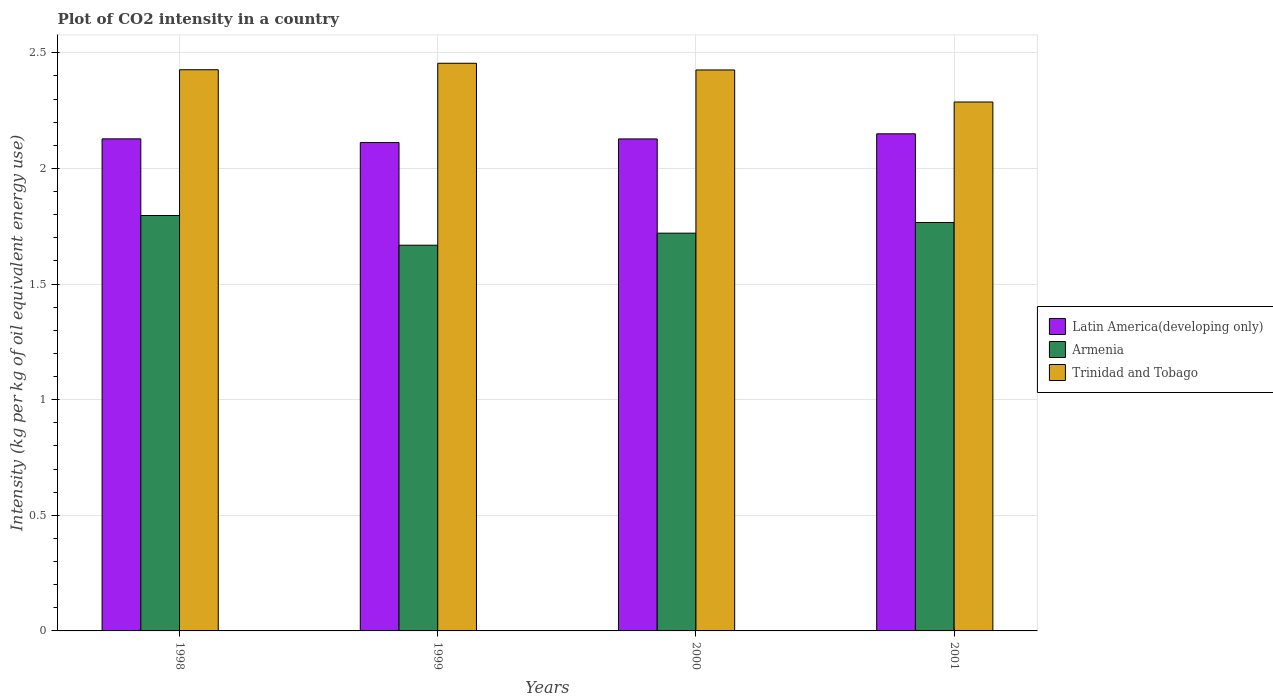How many different coloured bars are there?
Your answer should be very brief. 3. How many groups of bars are there?
Your answer should be compact. 4. Are the number of bars per tick equal to the number of legend labels?
Make the answer very short. Yes. How many bars are there on the 3rd tick from the right?
Offer a very short reply. 3. What is the label of the 4th group of bars from the left?
Offer a terse response. 2001. What is the CO2 intensity in in Trinidad and Tobago in 2001?
Offer a terse response. 2.29. Across all years, what is the maximum CO2 intensity in in Trinidad and Tobago?
Your response must be concise. 2.45. Across all years, what is the minimum CO2 intensity in in Trinidad and Tobago?
Your answer should be compact. 2.29. In which year was the CO2 intensity in in Trinidad and Tobago maximum?
Provide a succinct answer. 1999. What is the total CO2 intensity in in Armenia in the graph?
Keep it short and to the point. 6.95. What is the difference between the CO2 intensity in in Latin America(developing only) in 1999 and that in 2000?
Your answer should be very brief. -0.02. What is the difference between the CO2 intensity in in Armenia in 2000 and the CO2 intensity in in Latin America(developing only) in 2001?
Offer a very short reply. -0.43. What is the average CO2 intensity in in Armenia per year?
Ensure brevity in your answer.  1.74. In the year 1999, what is the difference between the CO2 intensity in in Armenia and CO2 intensity in in Latin America(developing only)?
Make the answer very short. -0.44. In how many years, is the CO2 intensity in in Trinidad and Tobago greater than 1.2 kg?
Ensure brevity in your answer.  4. What is the ratio of the CO2 intensity in in Trinidad and Tobago in 1999 to that in 2001?
Offer a terse response. 1.07. Is the CO2 intensity in in Trinidad and Tobago in 1998 less than that in 2001?
Your answer should be compact. No. What is the difference between the highest and the second highest CO2 intensity in in Armenia?
Offer a very short reply. 0.03. What is the difference between the highest and the lowest CO2 intensity in in Trinidad and Tobago?
Your response must be concise. 0.17. What does the 3rd bar from the left in 1999 represents?
Provide a short and direct response. Trinidad and Tobago. What does the 2nd bar from the right in 1998 represents?
Your response must be concise. Armenia. Is it the case that in every year, the sum of the CO2 intensity in in Trinidad and Tobago and CO2 intensity in in Armenia is greater than the CO2 intensity in in Latin America(developing only)?
Your response must be concise. Yes. Are all the bars in the graph horizontal?
Ensure brevity in your answer.  No. How many years are there in the graph?
Offer a very short reply. 4. What is the difference between two consecutive major ticks on the Y-axis?
Your answer should be very brief. 0.5. Where does the legend appear in the graph?
Your response must be concise. Center right. How many legend labels are there?
Your response must be concise. 3. How are the legend labels stacked?
Your answer should be very brief. Vertical. What is the title of the graph?
Your response must be concise. Plot of CO2 intensity in a country. Does "Tajikistan" appear as one of the legend labels in the graph?
Your response must be concise. No. What is the label or title of the Y-axis?
Provide a short and direct response. Intensity (kg per kg of oil equivalent energy use). What is the Intensity (kg per kg of oil equivalent energy use) of Latin America(developing only) in 1998?
Make the answer very short. 2.13. What is the Intensity (kg per kg of oil equivalent energy use) of Armenia in 1998?
Offer a very short reply. 1.8. What is the Intensity (kg per kg of oil equivalent energy use) of Trinidad and Tobago in 1998?
Provide a short and direct response. 2.43. What is the Intensity (kg per kg of oil equivalent energy use) in Latin America(developing only) in 1999?
Make the answer very short. 2.11. What is the Intensity (kg per kg of oil equivalent energy use) of Armenia in 1999?
Provide a short and direct response. 1.67. What is the Intensity (kg per kg of oil equivalent energy use) in Trinidad and Tobago in 1999?
Keep it short and to the point. 2.45. What is the Intensity (kg per kg of oil equivalent energy use) in Latin America(developing only) in 2000?
Offer a terse response. 2.13. What is the Intensity (kg per kg of oil equivalent energy use) in Armenia in 2000?
Make the answer very short. 1.72. What is the Intensity (kg per kg of oil equivalent energy use) of Trinidad and Tobago in 2000?
Ensure brevity in your answer.  2.43. What is the Intensity (kg per kg of oil equivalent energy use) in Latin America(developing only) in 2001?
Give a very brief answer. 2.15. What is the Intensity (kg per kg of oil equivalent energy use) in Armenia in 2001?
Offer a very short reply. 1.77. What is the Intensity (kg per kg of oil equivalent energy use) of Trinidad and Tobago in 2001?
Ensure brevity in your answer.  2.29. Across all years, what is the maximum Intensity (kg per kg of oil equivalent energy use) of Latin America(developing only)?
Make the answer very short. 2.15. Across all years, what is the maximum Intensity (kg per kg of oil equivalent energy use) of Armenia?
Offer a very short reply. 1.8. Across all years, what is the maximum Intensity (kg per kg of oil equivalent energy use) in Trinidad and Tobago?
Your response must be concise. 2.45. Across all years, what is the minimum Intensity (kg per kg of oil equivalent energy use) in Latin America(developing only)?
Your answer should be very brief. 2.11. Across all years, what is the minimum Intensity (kg per kg of oil equivalent energy use) in Armenia?
Provide a succinct answer. 1.67. Across all years, what is the minimum Intensity (kg per kg of oil equivalent energy use) of Trinidad and Tobago?
Your response must be concise. 2.29. What is the total Intensity (kg per kg of oil equivalent energy use) of Latin America(developing only) in the graph?
Your answer should be compact. 8.52. What is the total Intensity (kg per kg of oil equivalent energy use) in Armenia in the graph?
Provide a succinct answer. 6.95. What is the total Intensity (kg per kg of oil equivalent energy use) in Trinidad and Tobago in the graph?
Provide a succinct answer. 9.59. What is the difference between the Intensity (kg per kg of oil equivalent energy use) of Latin America(developing only) in 1998 and that in 1999?
Your answer should be compact. 0.02. What is the difference between the Intensity (kg per kg of oil equivalent energy use) of Armenia in 1998 and that in 1999?
Your answer should be compact. 0.13. What is the difference between the Intensity (kg per kg of oil equivalent energy use) in Trinidad and Tobago in 1998 and that in 1999?
Make the answer very short. -0.03. What is the difference between the Intensity (kg per kg of oil equivalent energy use) of Latin America(developing only) in 1998 and that in 2000?
Make the answer very short. 0. What is the difference between the Intensity (kg per kg of oil equivalent energy use) of Armenia in 1998 and that in 2000?
Give a very brief answer. 0.08. What is the difference between the Intensity (kg per kg of oil equivalent energy use) in Trinidad and Tobago in 1998 and that in 2000?
Make the answer very short. 0. What is the difference between the Intensity (kg per kg of oil equivalent energy use) in Latin America(developing only) in 1998 and that in 2001?
Ensure brevity in your answer.  -0.02. What is the difference between the Intensity (kg per kg of oil equivalent energy use) in Armenia in 1998 and that in 2001?
Give a very brief answer. 0.03. What is the difference between the Intensity (kg per kg of oil equivalent energy use) in Trinidad and Tobago in 1998 and that in 2001?
Give a very brief answer. 0.14. What is the difference between the Intensity (kg per kg of oil equivalent energy use) in Latin America(developing only) in 1999 and that in 2000?
Provide a short and direct response. -0.02. What is the difference between the Intensity (kg per kg of oil equivalent energy use) of Armenia in 1999 and that in 2000?
Keep it short and to the point. -0.05. What is the difference between the Intensity (kg per kg of oil equivalent energy use) of Trinidad and Tobago in 1999 and that in 2000?
Offer a terse response. 0.03. What is the difference between the Intensity (kg per kg of oil equivalent energy use) of Latin America(developing only) in 1999 and that in 2001?
Give a very brief answer. -0.04. What is the difference between the Intensity (kg per kg of oil equivalent energy use) in Armenia in 1999 and that in 2001?
Offer a very short reply. -0.1. What is the difference between the Intensity (kg per kg of oil equivalent energy use) of Trinidad and Tobago in 1999 and that in 2001?
Give a very brief answer. 0.17. What is the difference between the Intensity (kg per kg of oil equivalent energy use) in Latin America(developing only) in 2000 and that in 2001?
Ensure brevity in your answer.  -0.02. What is the difference between the Intensity (kg per kg of oil equivalent energy use) in Armenia in 2000 and that in 2001?
Offer a very short reply. -0.05. What is the difference between the Intensity (kg per kg of oil equivalent energy use) in Trinidad and Tobago in 2000 and that in 2001?
Keep it short and to the point. 0.14. What is the difference between the Intensity (kg per kg of oil equivalent energy use) of Latin America(developing only) in 1998 and the Intensity (kg per kg of oil equivalent energy use) of Armenia in 1999?
Your answer should be compact. 0.46. What is the difference between the Intensity (kg per kg of oil equivalent energy use) in Latin America(developing only) in 1998 and the Intensity (kg per kg of oil equivalent energy use) in Trinidad and Tobago in 1999?
Offer a very short reply. -0.33. What is the difference between the Intensity (kg per kg of oil equivalent energy use) of Armenia in 1998 and the Intensity (kg per kg of oil equivalent energy use) of Trinidad and Tobago in 1999?
Your answer should be compact. -0.66. What is the difference between the Intensity (kg per kg of oil equivalent energy use) of Latin America(developing only) in 1998 and the Intensity (kg per kg of oil equivalent energy use) of Armenia in 2000?
Keep it short and to the point. 0.41. What is the difference between the Intensity (kg per kg of oil equivalent energy use) in Latin America(developing only) in 1998 and the Intensity (kg per kg of oil equivalent energy use) in Trinidad and Tobago in 2000?
Offer a terse response. -0.3. What is the difference between the Intensity (kg per kg of oil equivalent energy use) in Armenia in 1998 and the Intensity (kg per kg of oil equivalent energy use) in Trinidad and Tobago in 2000?
Give a very brief answer. -0.63. What is the difference between the Intensity (kg per kg of oil equivalent energy use) in Latin America(developing only) in 1998 and the Intensity (kg per kg of oil equivalent energy use) in Armenia in 2001?
Offer a very short reply. 0.36. What is the difference between the Intensity (kg per kg of oil equivalent energy use) in Latin America(developing only) in 1998 and the Intensity (kg per kg of oil equivalent energy use) in Trinidad and Tobago in 2001?
Provide a succinct answer. -0.16. What is the difference between the Intensity (kg per kg of oil equivalent energy use) in Armenia in 1998 and the Intensity (kg per kg of oil equivalent energy use) in Trinidad and Tobago in 2001?
Keep it short and to the point. -0.49. What is the difference between the Intensity (kg per kg of oil equivalent energy use) of Latin America(developing only) in 1999 and the Intensity (kg per kg of oil equivalent energy use) of Armenia in 2000?
Ensure brevity in your answer.  0.39. What is the difference between the Intensity (kg per kg of oil equivalent energy use) in Latin America(developing only) in 1999 and the Intensity (kg per kg of oil equivalent energy use) in Trinidad and Tobago in 2000?
Your answer should be very brief. -0.31. What is the difference between the Intensity (kg per kg of oil equivalent energy use) of Armenia in 1999 and the Intensity (kg per kg of oil equivalent energy use) of Trinidad and Tobago in 2000?
Ensure brevity in your answer.  -0.76. What is the difference between the Intensity (kg per kg of oil equivalent energy use) in Latin America(developing only) in 1999 and the Intensity (kg per kg of oil equivalent energy use) in Armenia in 2001?
Your answer should be compact. 0.35. What is the difference between the Intensity (kg per kg of oil equivalent energy use) of Latin America(developing only) in 1999 and the Intensity (kg per kg of oil equivalent energy use) of Trinidad and Tobago in 2001?
Ensure brevity in your answer.  -0.18. What is the difference between the Intensity (kg per kg of oil equivalent energy use) of Armenia in 1999 and the Intensity (kg per kg of oil equivalent energy use) of Trinidad and Tobago in 2001?
Your answer should be compact. -0.62. What is the difference between the Intensity (kg per kg of oil equivalent energy use) in Latin America(developing only) in 2000 and the Intensity (kg per kg of oil equivalent energy use) in Armenia in 2001?
Make the answer very short. 0.36. What is the difference between the Intensity (kg per kg of oil equivalent energy use) in Latin America(developing only) in 2000 and the Intensity (kg per kg of oil equivalent energy use) in Trinidad and Tobago in 2001?
Offer a very short reply. -0.16. What is the difference between the Intensity (kg per kg of oil equivalent energy use) in Armenia in 2000 and the Intensity (kg per kg of oil equivalent energy use) in Trinidad and Tobago in 2001?
Your answer should be compact. -0.57. What is the average Intensity (kg per kg of oil equivalent energy use) of Latin America(developing only) per year?
Keep it short and to the point. 2.13. What is the average Intensity (kg per kg of oil equivalent energy use) of Armenia per year?
Provide a short and direct response. 1.74. What is the average Intensity (kg per kg of oil equivalent energy use) of Trinidad and Tobago per year?
Ensure brevity in your answer.  2.4. In the year 1998, what is the difference between the Intensity (kg per kg of oil equivalent energy use) of Latin America(developing only) and Intensity (kg per kg of oil equivalent energy use) of Armenia?
Keep it short and to the point. 0.33. In the year 1998, what is the difference between the Intensity (kg per kg of oil equivalent energy use) of Latin America(developing only) and Intensity (kg per kg of oil equivalent energy use) of Trinidad and Tobago?
Provide a short and direct response. -0.3. In the year 1998, what is the difference between the Intensity (kg per kg of oil equivalent energy use) in Armenia and Intensity (kg per kg of oil equivalent energy use) in Trinidad and Tobago?
Provide a short and direct response. -0.63. In the year 1999, what is the difference between the Intensity (kg per kg of oil equivalent energy use) of Latin America(developing only) and Intensity (kg per kg of oil equivalent energy use) of Armenia?
Keep it short and to the point. 0.44. In the year 1999, what is the difference between the Intensity (kg per kg of oil equivalent energy use) in Latin America(developing only) and Intensity (kg per kg of oil equivalent energy use) in Trinidad and Tobago?
Ensure brevity in your answer.  -0.34. In the year 1999, what is the difference between the Intensity (kg per kg of oil equivalent energy use) in Armenia and Intensity (kg per kg of oil equivalent energy use) in Trinidad and Tobago?
Offer a terse response. -0.79. In the year 2000, what is the difference between the Intensity (kg per kg of oil equivalent energy use) in Latin America(developing only) and Intensity (kg per kg of oil equivalent energy use) in Armenia?
Your response must be concise. 0.41. In the year 2000, what is the difference between the Intensity (kg per kg of oil equivalent energy use) of Latin America(developing only) and Intensity (kg per kg of oil equivalent energy use) of Trinidad and Tobago?
Provide a succinct answer. -0.3. In the year 2000, what is the difference between the Intensity (kg per kg of oil equivalent energy use) of Armenia and Intensity (kg per kg of oil equivalent energy use) of Trinidad and Tobago?
Offer a very short reply. -0.71. In the year 2001, what is the difference between the Intensity (kg per kg of oil equivalent energy use) in Latin America(developing only) and Intensity (kg per kg of oil equivalent energy use) in Armenia?
Provide a succinct answer. 0.38. In the year 2001, what is the difference between the Intensity (kg per kg of oil equivalent energy use) in Latin America(developing only) and Intensity (kg per kg of oil equivalent energy use) in Trinidad and Tobago?
Your answer should be compact. -0.14. In the year 2001, what is the difference between the Intensity (kg per kg of oil equivalent energy use) in Armenia and Intensity (kg per kg of oil equivalent energy use) in Trinidad and Tobago?
Your response must be concise. -0.52. What is the ratio of the Intensity (kg per kg of oil equivalent energy use) in Latin America(developing only) in 1998 to that in 1999?
Your answer should be very brief. 1.01. What is the ratio of the Intensity (kg per kg of oil equivalent energy use) of Armenia in 1998 to that in 1999?
Your answer should be compact. 1.08. What is the ratio of the Intensity (kg per kg of oil equivalent energy use) of Trinidad and Tobago in 1998 to that in 1999?
Your answer should be compact. 0.99. What is the ratio of the Intensity (kg per kg of oil equivalent energy use) in Armenia in 1998 to that in 2000?
Make the answer very short. 1.04. What is the ratio of the Intensity (kg per kg of oil equivalent energy use) in Latin America(developing only) in 1998 to that in 2001?
Offer a terse response. 0.99. What is the ratio of the Intensity (kg per kg of oil equivalent energy use) in Armenia in 1998 to that in 2001?
Give a very brief answer. 1.02. What is the ratio of the Intensity (kg per kg of oil equivalent energy use) in Trinidad and Tobago in 1998 to that in 2001?
Your answer should be very brief. 1.06. What is the ratio of the Intensity (kg per kg of oil equivalent energy use) in Latin America(developing only) in 1999 to that in 2000?
Ensure brevity in your answer.  0.99. What is the ratio of the Intensity (kg per kg of oil equivalent energy use) of Armenia in 1999 to that in 2000?
Your response must be concise. 0.97. What is the ratio of the Intensity (kg per kg of oil equivalent energy use) in Latin America(developing only) in 1999 to that in 2001?
Offer a very short reply. 0.98. What is the ratio of the Intensity (kg per kg of oil equivalent energy use) in Armenia in 1999 to that in 2001?
Give a very brief answer. 0.94. What is the ratio of the Intensity (kg per kg of oil equivalent energy use) in Trinidad and Tobago in 1999 to that in 2001?
Ensure brevity in your answer.  1.07. What is the ratio of the Intensity (kg per kg of oil equivalent energy use) of Latin America(developing only) in 2000 to that in 2001?
Keep it short and to the point. 0.99. What is the ratio of the Intensity (kg per kg of oil equivalent energy use) of Armenia in 2000 to that in 2001?
Keep it short and to the point. 0.97. What is the ratio of the Intensity (kg per kg of oil equivalent energy use) of Trinidad and Tobago in 2000 to that in 2001?
Keep it short and to the point. 1.06. What is the difference between the highest and the second highest Intensity (kg per kg of oil equivalent energy use) of Latin America(developing only)?
Give a very brief answer. 0.02. What is the difference between the highest and the second highest Intensity (kg per kg of oil equivalent energy use) in Armenia?
Make the answer very short. 0.03. What is the difference between the highest and the second highest Intensity (kg per kg of oil equivalent energy use) of Trinidad and Tobago?
Offer a terse response. 0.03. What is the difference between the highest and the lowest Intensity (kg per kg of oil equivalent energy use) of Latin America(developing only)?
Your answer should be compact. 0.04. What is the difference between the highest and the lowest Intensity (kg per kg of oil equivalent energy use) in Armenia?
Your answer should be very brief. 0.13. What is the difference between the highest and the lowest Intensity (kg per kg of oil equivalent energy use) in Trinidad and Tobago?
Offer a very short reply. 0.17. 